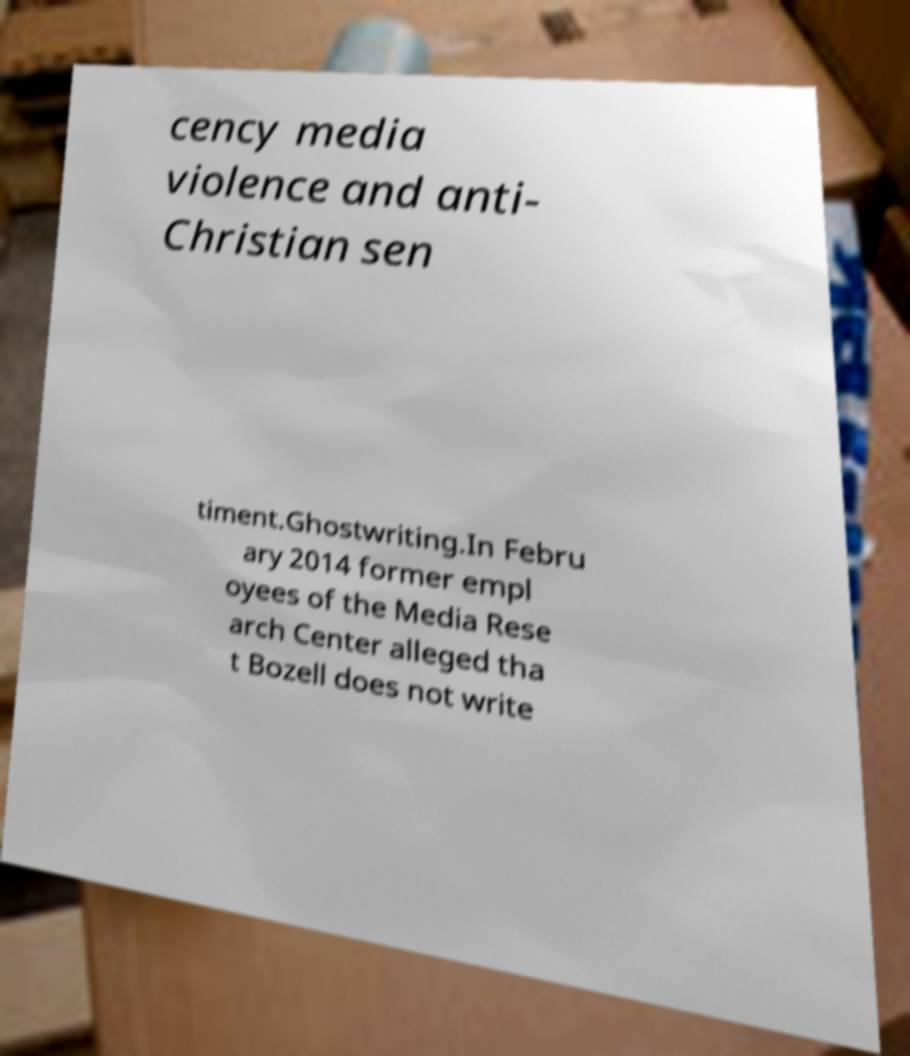For documentation purposes, I need the text within this image transcribed. Could you provide that? cency media violence and anti- Christian sen timent.Ghostwriting.In Febru ary 2014 former empl oyees of the Media Rese arch Center alleged tha t Bozell does not write 